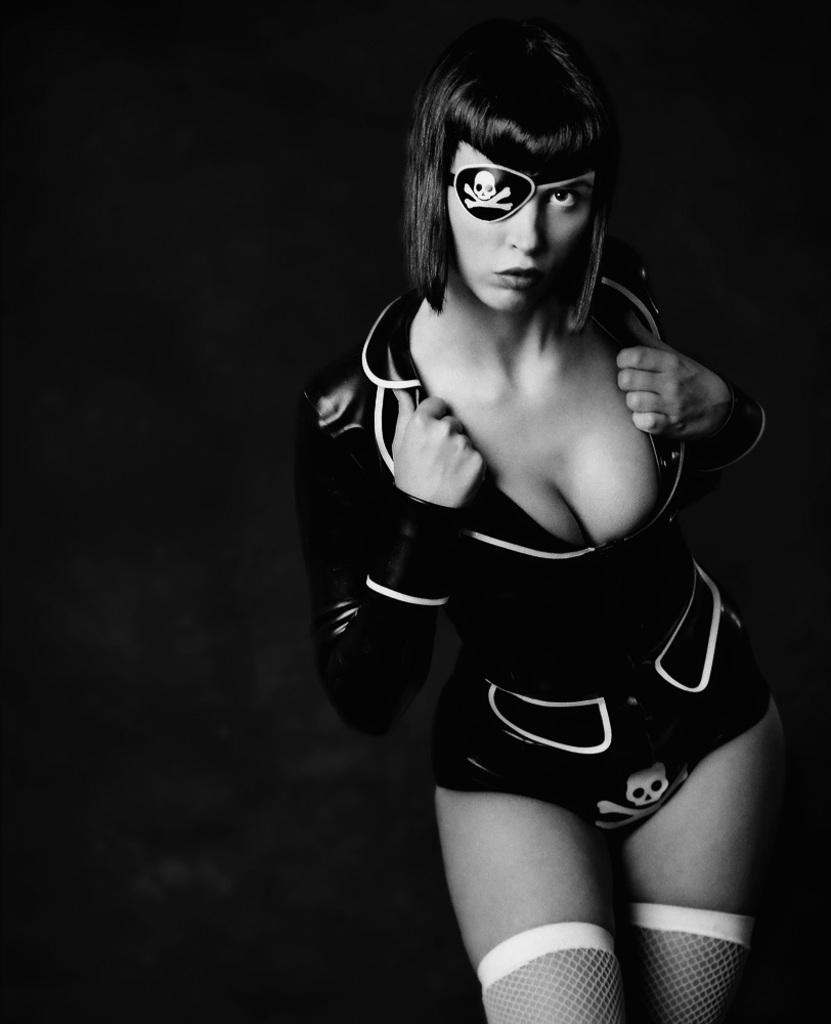What type of image is present in the picture? The image contains a black and white photograph. What is the subject of the photograph? The photograph depicts a woman standing. What is the woman doing in the photograph? The woman is showing her dress. What is the background of the photograph? There is a black surface visible behind the woman in the photograph. How many fangs can be seen in the photograph? There are no fangs present in the photograph; it features a woman standing and showing her dress. What type of land is visible in the photograph? The photograph is a black and white image, and there is no visible land in the photograph. 